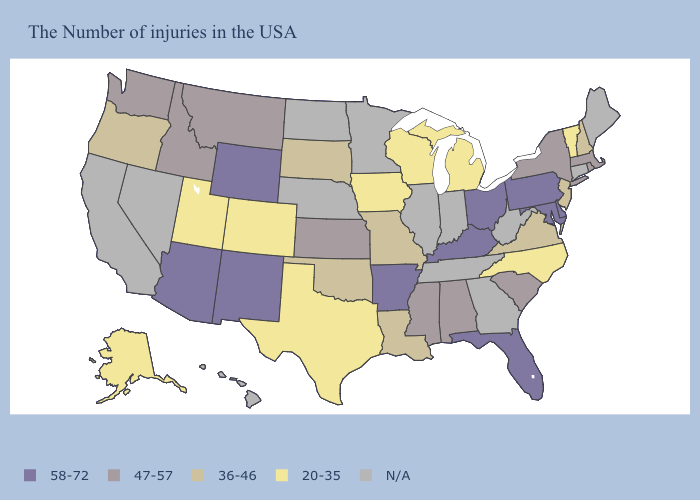Name the states that have a value in the range 58-72?
Be succinct. Delaware, Maryland, Pennsylvania, Ohio, Florida, Kentucky, Arkansas, Wyoming, New Mexico, Arizona. Among the states that border New Mexico , which have the highest value?
Keep it brief. Arizona. What is the value of Georgia?
Quick response, please. N/A. Which states have the highest value in the USA?
Be succinct. Delaware, Maryland, Pennsylvania, Ohio, Florida, Kentucky, Arkansas, Wyoming, New Mexico, Arizona. What is the value of Massachusetts?
Give a very brief answer. 47-57. What is the value of Wyoming?
Answer briefly. 58-72. What is the highest value in the Northeast ?
Short answer required. 58-72. Among the states that border South Carolina , which have the lowest value?
Concise answer only. North Carolina. What is the lowest value in states that border Michigan?
Concise answer only. 20-35. Does the first symbol in the legend represent the smallest category?
Keep it brief. No. What is the value of Delaware?
Short answer required. 58-72. What is the value of Tennessee?
Concise answer only. N/A. What is the value of Maine?
Write a very short answer. N/A. 